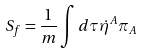<formula> <loc_0><loc_0><loc_500><loc_500>S _ { f } = \frac { 1 } { m } \int d \tau \dot { \eta } ^ { A } \pi _ { A }</formula> 